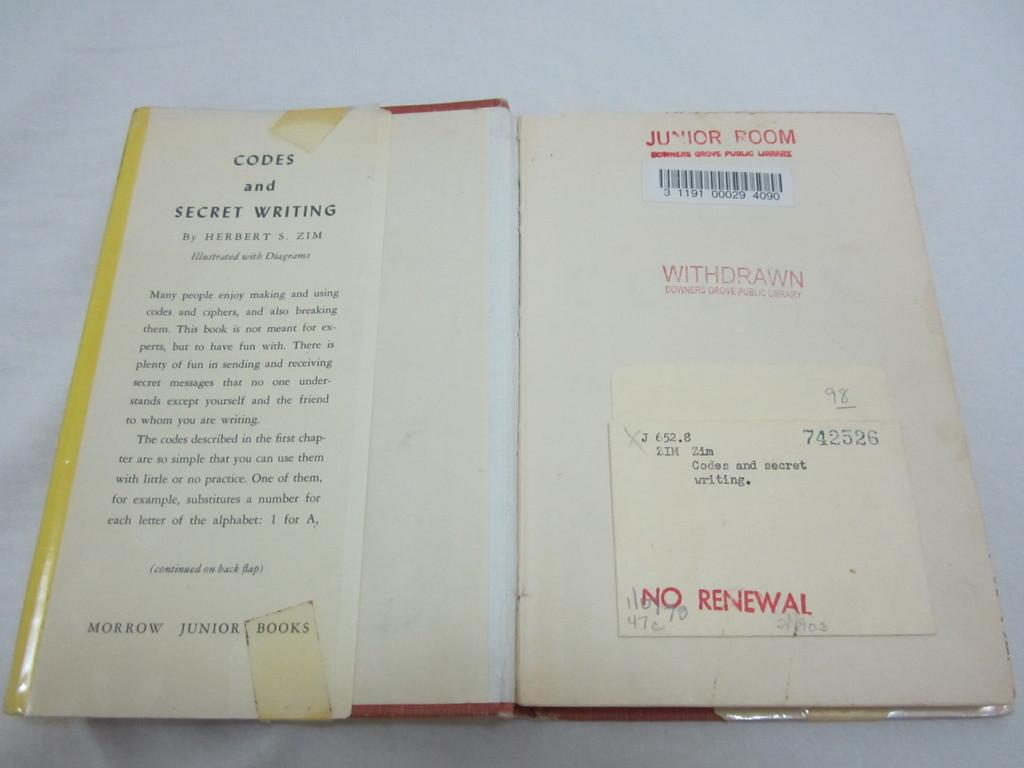<image>
Share a concise interpretation of the image provided. A book titled Codes and Secret Writing opened on the first page. 